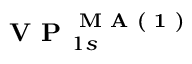Convert formula to latex. <formula><loc_0><loc_0><loc_500><loc_500>V P _ { 1 s } ^ { M A ( 1 ) }</formula> 